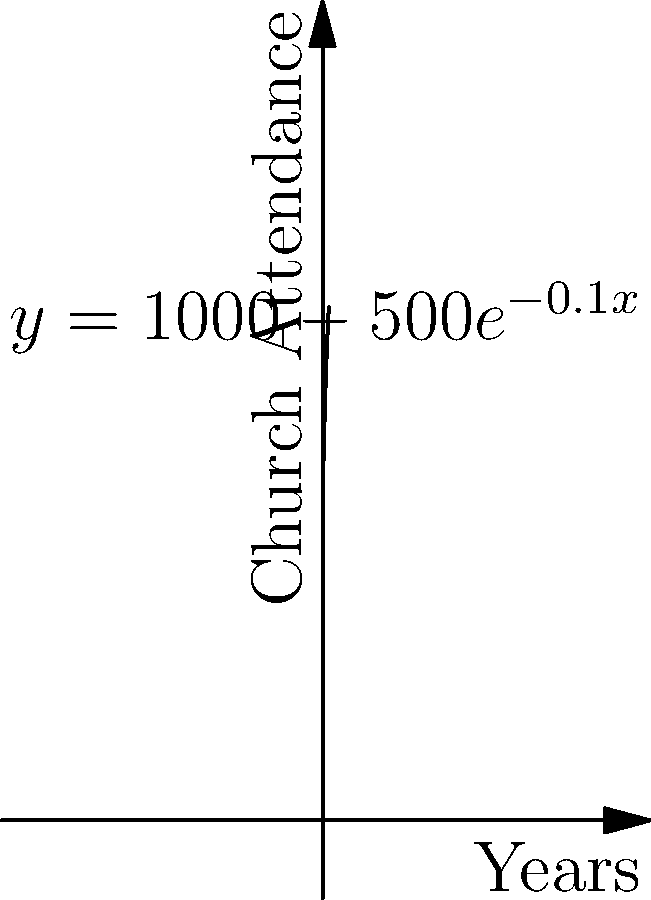The curve above represents church attendance over time, given by the function $y = 1000 - 500e^{-0.1x}$, where $y$ is the number of attendees and $x$ is the number of years since a social justice program was implemented. At what rate is church attendance increasing after 5 years? To find the rate of change in church attendance after 5 years, we need to follow these steps:

1. The rate of change is given by the derivative of the function.

2. Let's derive the function $y = 1000 - 500e^{-0.1x}$:
   $$\frac{dy}{dx} = -500 \cdot (-0.1e^{-0.1x}) = 50e^{-0.1x}$$

3. Now we have the rate of change function. To find the rate after 5 years, we substitute $x = 5$:
   $$\frac{dy}{dx}|_{x=5} = 50e^{-0.1(5)} = 50e^{-0.5}$$

4. Calculate this value:
   $$50e^{-0.5} \approx 30.33$$

Therefore, after 5 years, the church attendance is increasing at a rate of approximately 30.33 people per year.
Answer: 30.33 people per year 